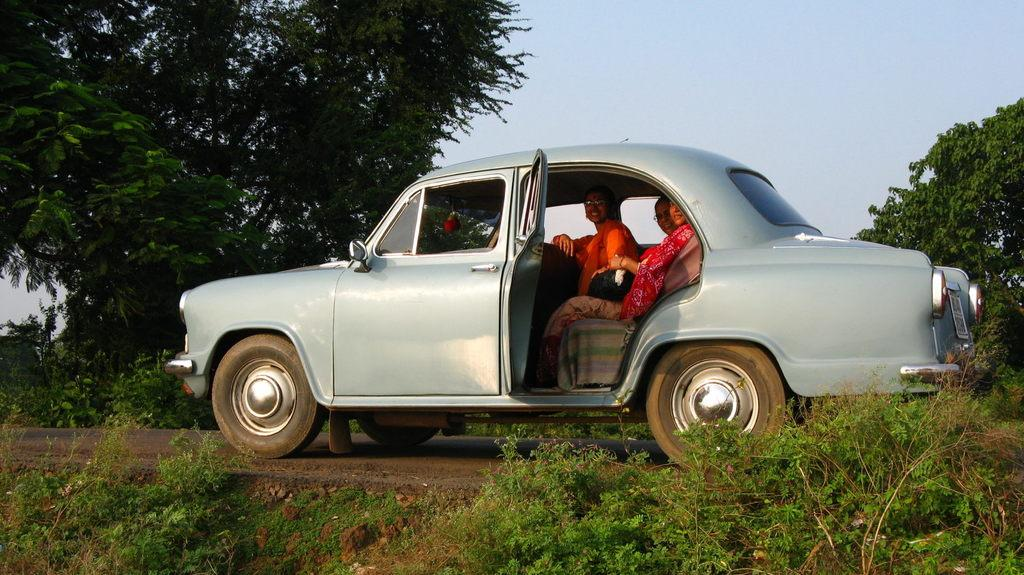What is the main subject of the image? The main subject of the image is a car. Who or what is inside the car? There are people sitting inside the car. What is the emotional state of the people in the car? The people are smiling. What can be seen in the background of the image? Plants, grass, trees, and the sky are visible in the background. What type of pickle is being taught to the people in the car? There is no pickle present in the image, nor is anyone teaching anything. 